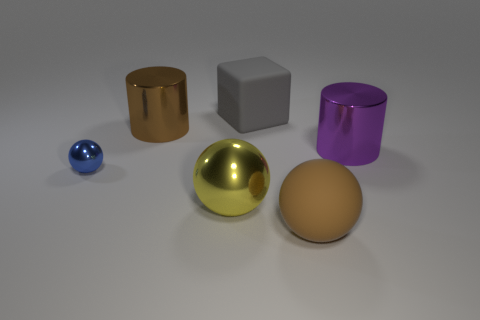Add 3 big gray things. How many objects exist? 9 Subtract all blocks. How many objects are left? 5 Subtract 0 red cylinders. How many objects are left? 6 Subtract all big brown cylinders. Subtract all brown rubber balls. How many objects are left? 4 Add 2 small objects. How many small objects are left? 3 Add 2 tiny objects. How many tiny objects exist? 3 